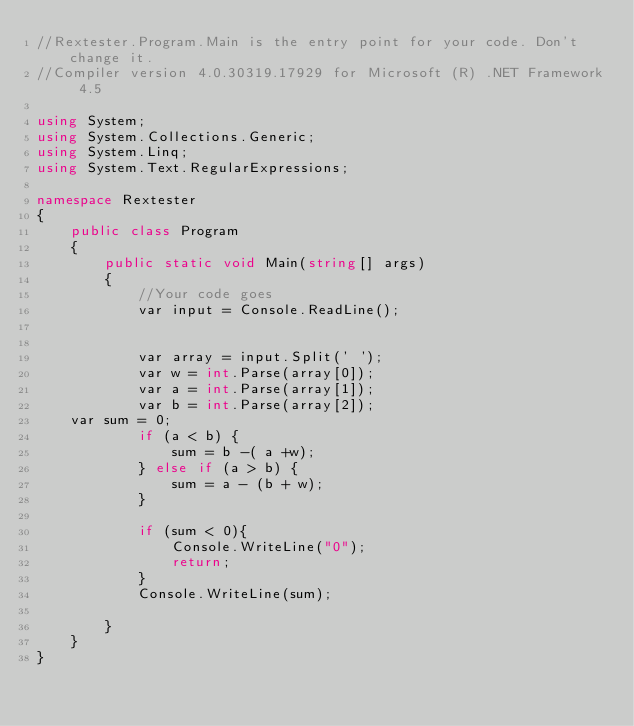<code> <loc_0><loc_0><loc_500><loc_500><_C#_>//Rextester.Program.Main is the entry point for your code. Don't change it.
//Compiler version 4.0.30319.17929 for Microsoft (R) .NET Framework 4.5

using System;
using System.Collections.Generic;
using System.Linq;
using System.Text.RegularExpressions;

namespace Rextester
{
    public class Program
    {
        public static void Main(string[] args)
        {
            //Your code goes 
            var input = Console.ReadLine();


            var array = input.Split(' ');
            var w = int.Parse(array[0]);
            var a = int.Parse(array[1]);
            var b = int.Parse(array[2]);
    var sum = 0;
            if (a < b) {
                sum = b -( a +w);
            } else if (a > b) {
                sum = a - (b + w);
            }
            
            if (sum < 0){
                Console.WriteLine("0");
                return;
            }
            Console.WriteLine(sum);
                               
        }
    }
}</code> 